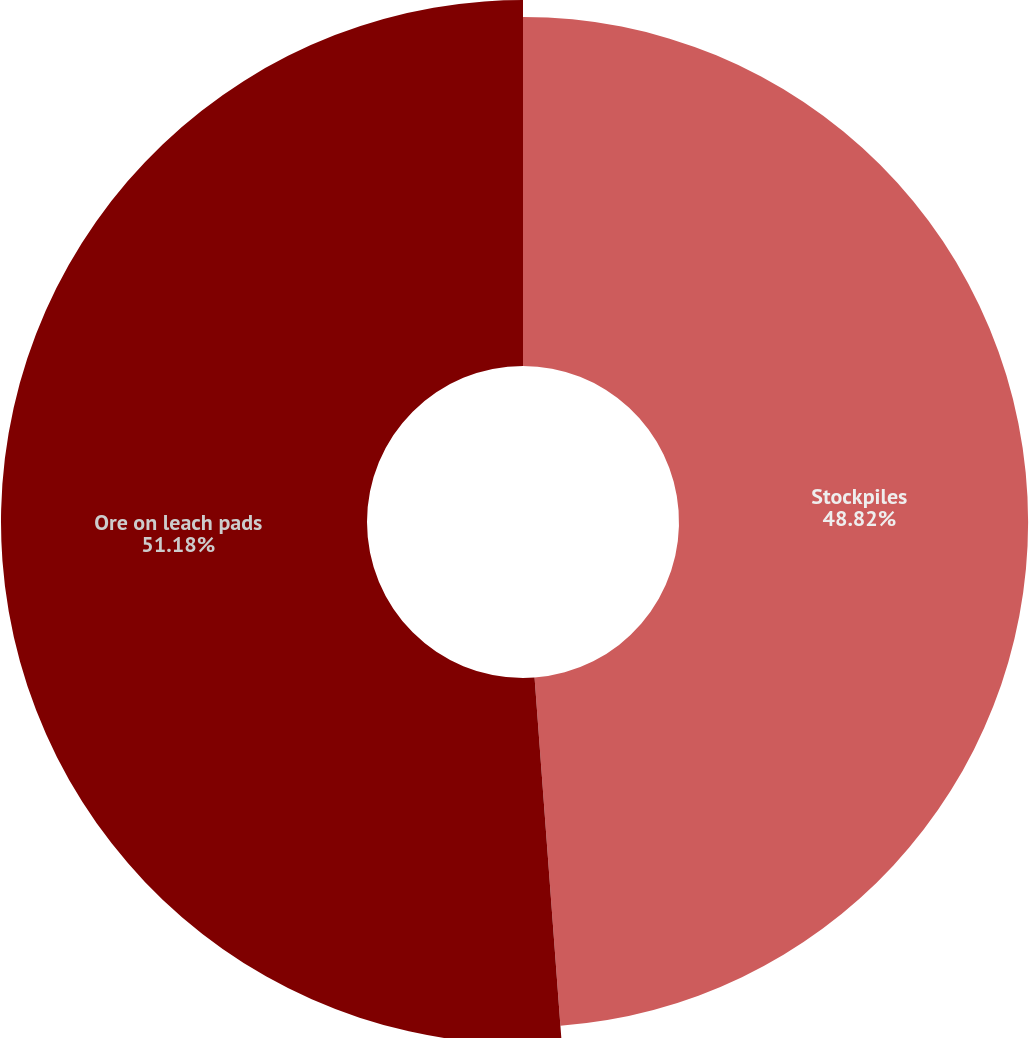<chart> <loc_0><loc_0><loc_500><loc_500><pie_chart><fcel>Stockpiles<fcel>Ore on leach pads<nl><fcel>48.82%<fcel>51.18%<nl></chart> 